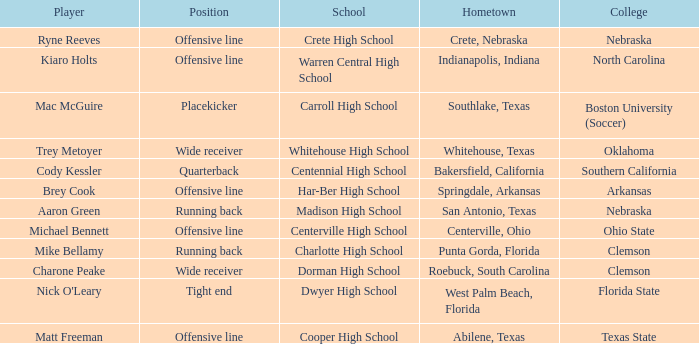What was the position of the player that went to warren central high school? Offensive line. 